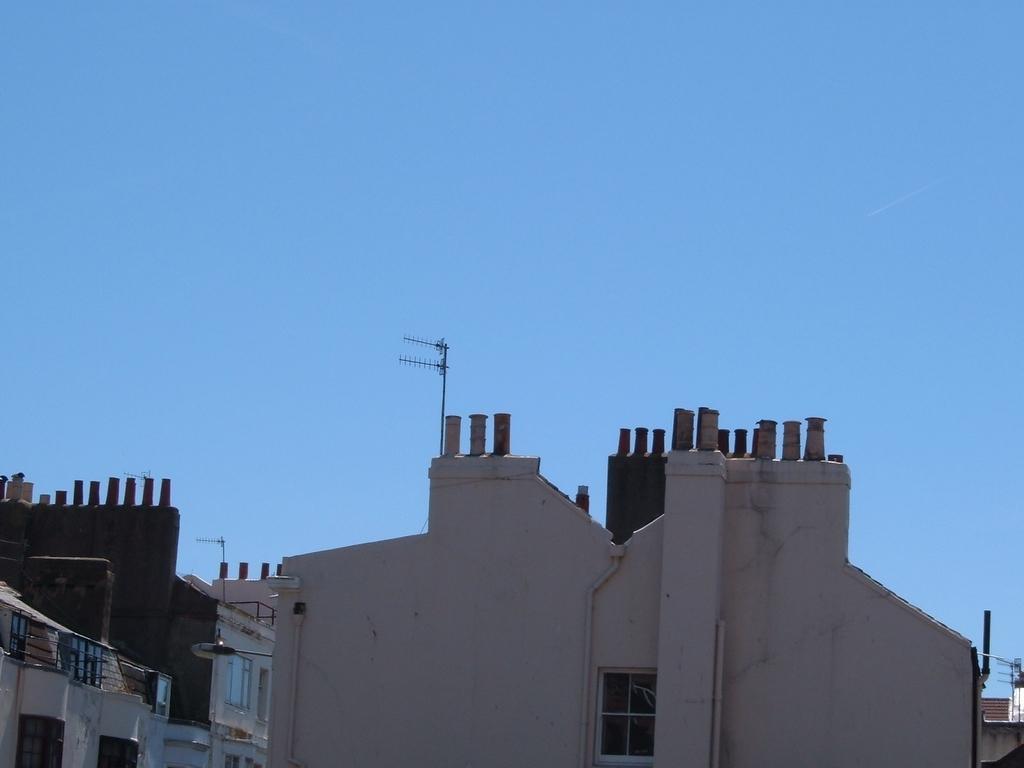Please provide a concise description of this image. In the center of the image there are buildings. At the top there is sky. 